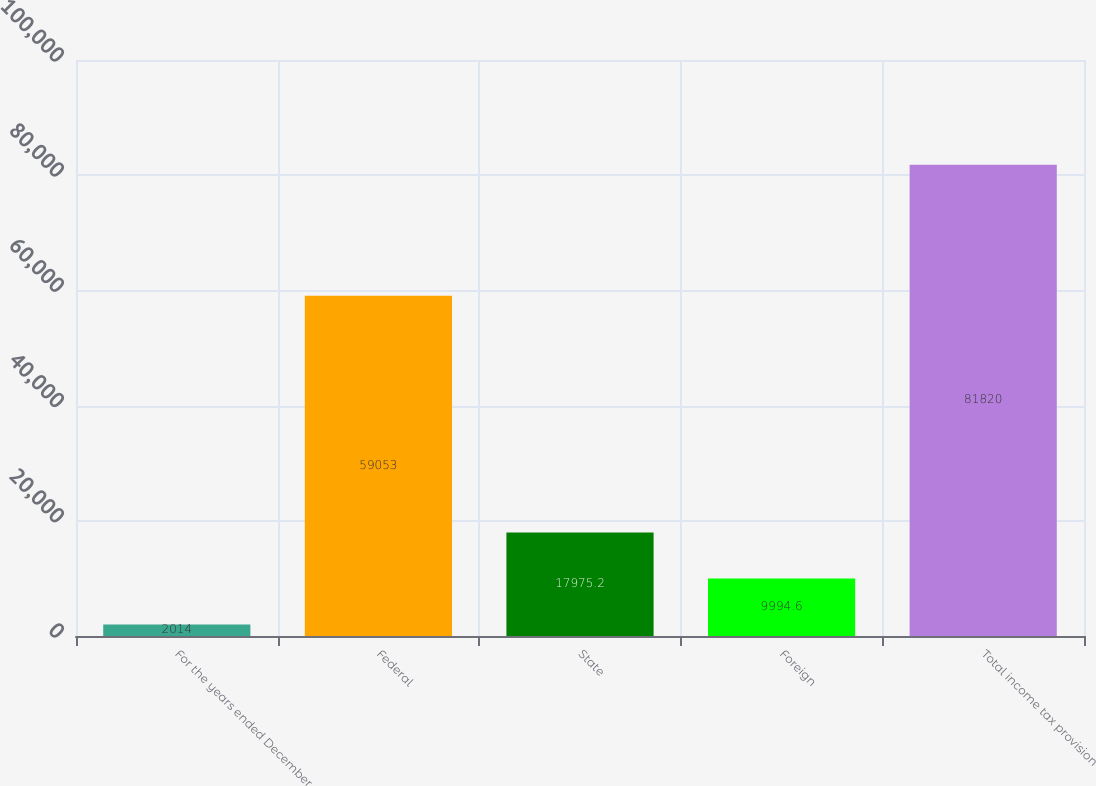Convert chart to OTSL. <chart><loc_0><loc_0><loc_500><loc_500><bar_chart><fcel>For the years ended December<fcel>Federal<fcel>State<fcel>Foreign<fcel>Total income tax provision<nl><fcel>2014<fcel>59053<fcel>17975.2<fcel>9994.6<fcel>81820<nl></chart> 